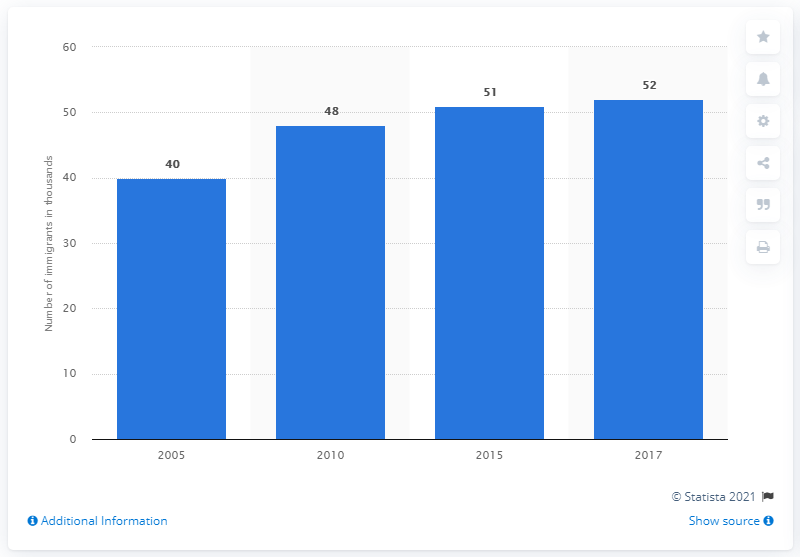List a handful of essential elements in this visual. In 2010, it is estimated that 48,000 immigrants lived in Bhutan. 